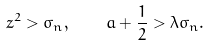<formula> <loc_0><loc_0><loc_500><loc_500>z ^ { 2 } > \sigma _ { n } , \quad a + \frac { 1 } { 2 } > \lambda \sigma _ { n } .</formula> 